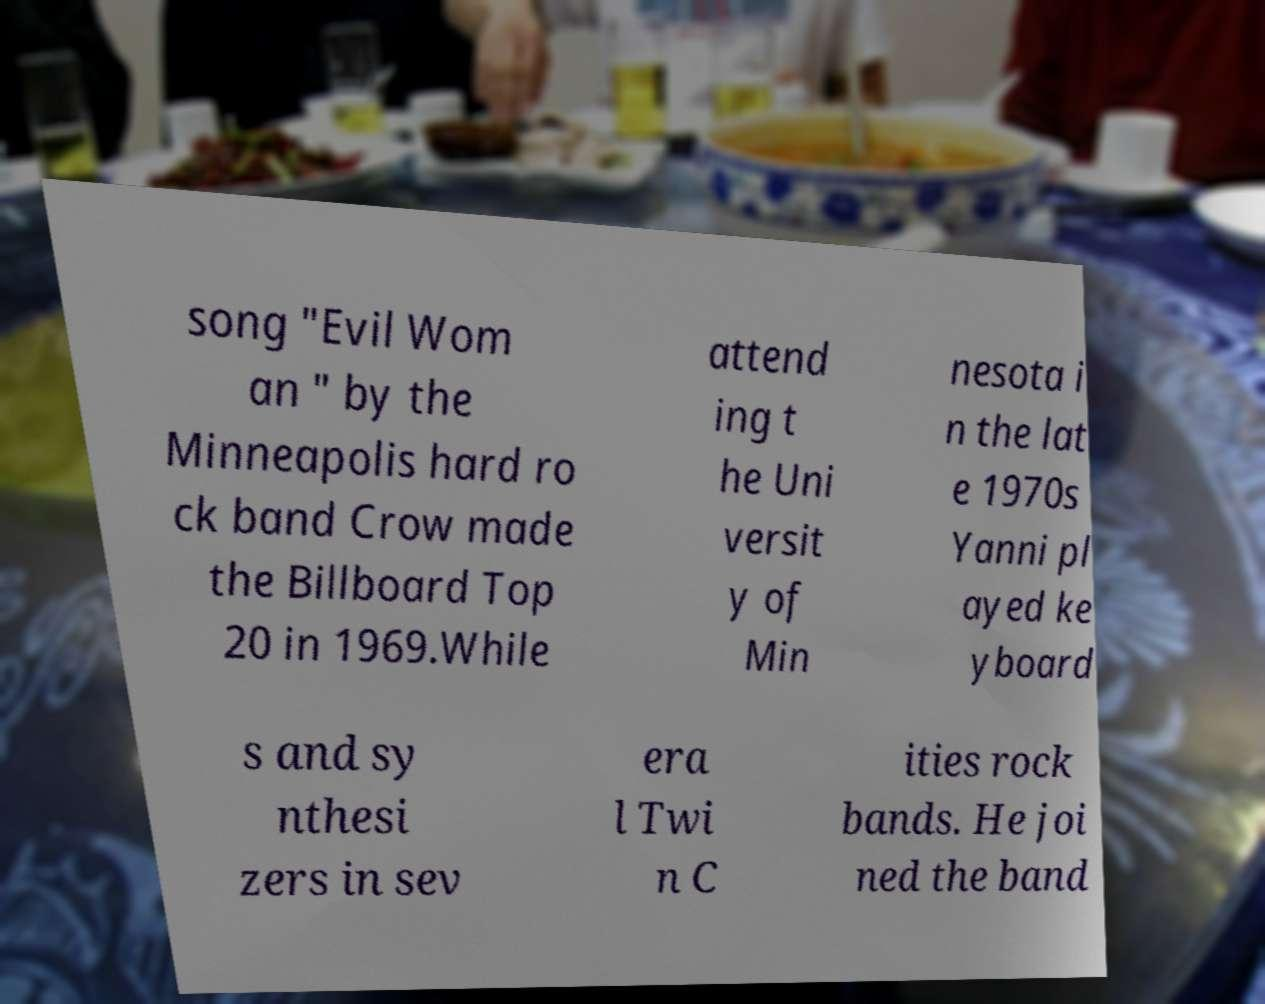Could you extract and type out the text from this image? song "Evil Wom an " by the Minneapolis hard ro ck band Crow made the Billboard Top 20 in 1969.While attend ing t he Uni versit y of Min nesota i n the lat e 1970s Yanni pl ayed ke yboard s and sy nthesi zers in sev era l Twi n C ities rock bands. He joi ned the band 